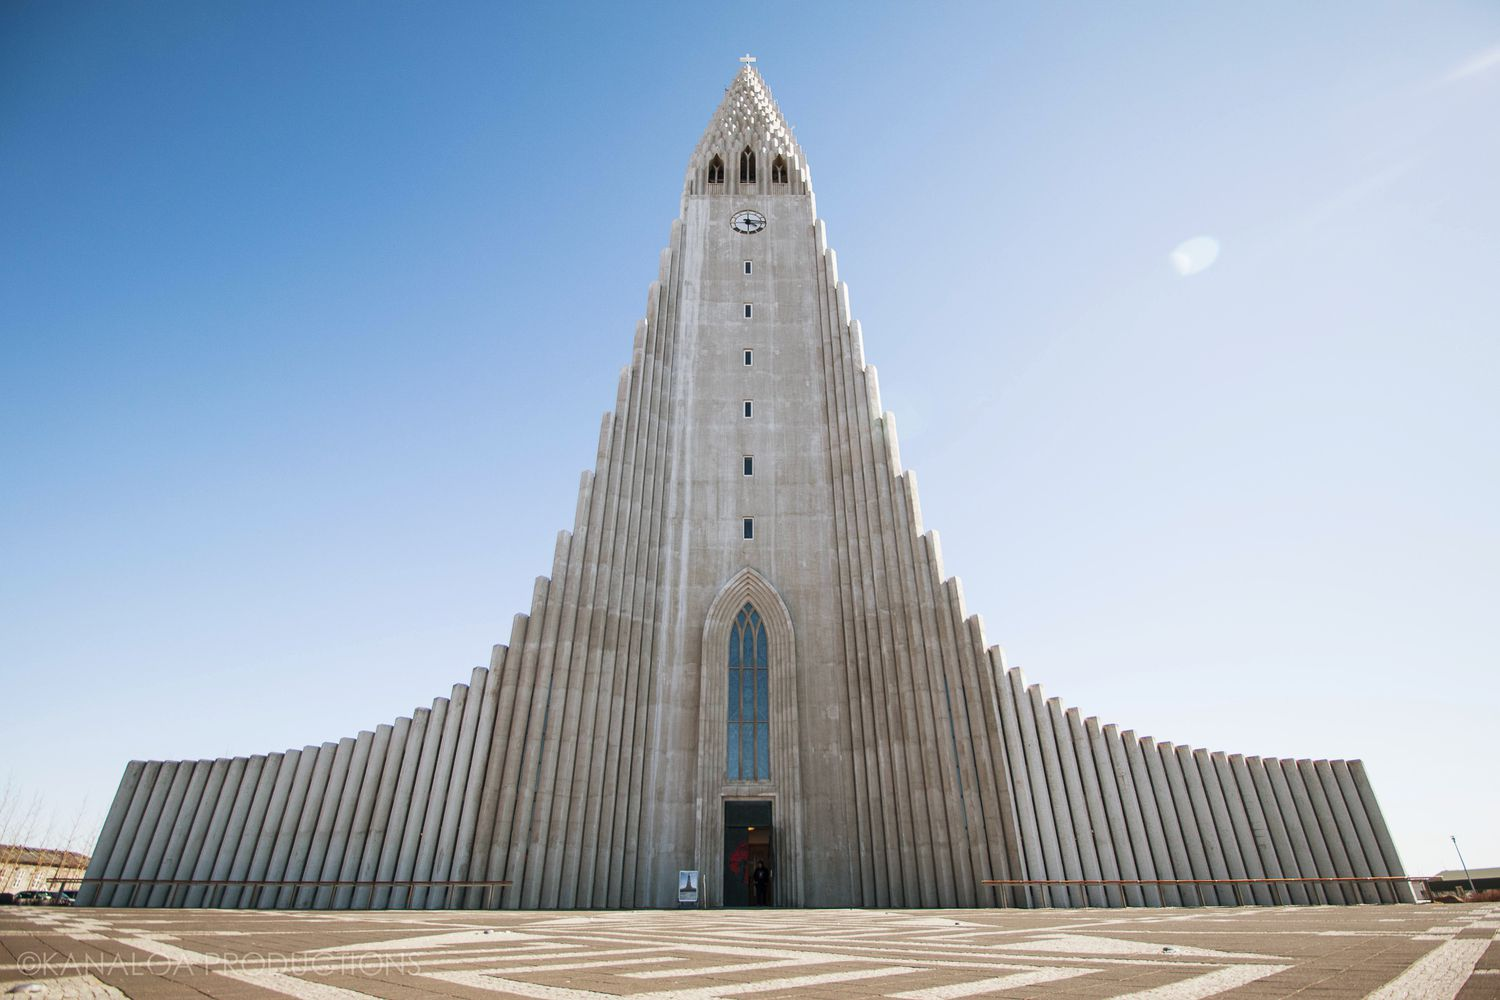In a realistic scenario, how do local residents interact with this church? Local residents frequently visit Hallgrímskirkja for various purposes. Some attend regular church services and community gatherings, finding spiritual solace and community support. The church's observation tower, offering panoramic views of Reykjavík, is a popular spot for both residents and tourists. During holidays and festivals, the church hosts special events and concerts, becoming a central hub for cultural and religious celebrations. For many locals, a simple walk around the church grounds, with its beautiful architecture and tranquil surroundings, offers a moment of peace in their daily lives. 